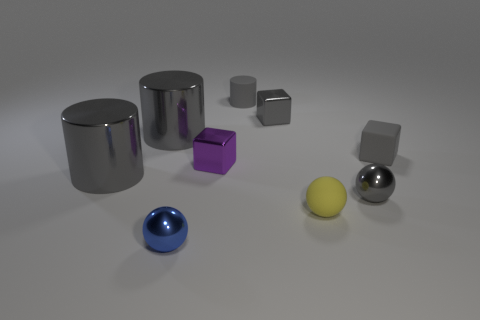There is a yellow matte object that is the same size as the rubber cylinder; what shape is it?
Your answer should be compact. Sphere. There is a large metal cylinder that is in front of the purple metal thing; is there a small gray sphere on the left side of it?
Your response must be concise. No. How many large things are either gray blocks or gray matte blocks?
Make the answer very short. 0. Are there any other shiny objects of the same size as the blue metallic thing?
Provide a succinct answer. Yes. Are there the same number of big purple matte things and rubber cylinders?
Ensure brevity in your answer.  No. What number of metallic objects are either small gray objects or small yellow things?
Give a very brief answer. 2. What is the shape of the rubber thing that is the same color as the rubber cylinder?
Your answer should be very brief. Cube. How many matte balls are there?
Your answer should be compact. 1. Is the material of the small ball behind the matte sphere the same as the big object behind the purple block?
Your answer should be compact. Yes. There is a cube that is the same material as the tiny purple object; what is its size?
Give a very brief answer. Small. 